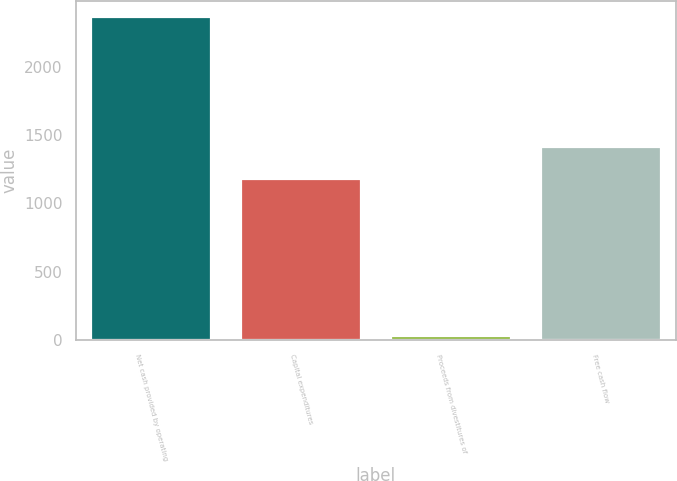Convert chart to OTSL. <chart><loc_0><loc_0><loc_500><loc_500><bar_chart><fcel>Net cash provided by operating<fcel>Capital expenditures<fcel>Proceeds from divestitures of<fcel>Free cash flow<nl><fcel>2362<fcel>1179<fcel>28<fcel>1412.4<nl></chart> 